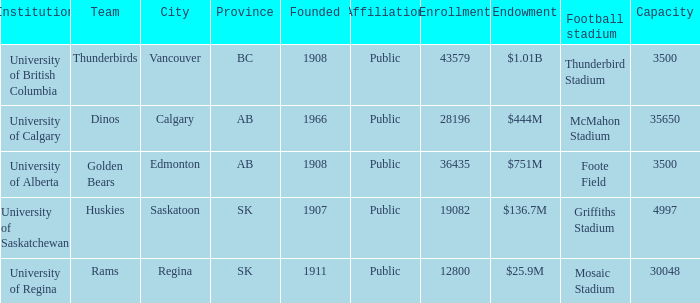Which organization has a $2 University of Regina. 